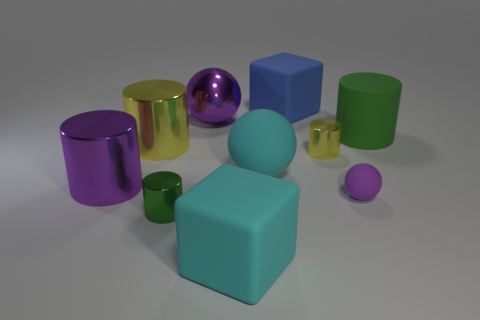Subtract all purple cylinders. How many cylinders are left? 4 Subtract all green blocks. How many yellow cylinders are left? 2 Subtract all yellow cylinders. How many cylinders are left? 3 Subtract 1 balls. How many balls are left? 2 Subtract all spheres. How many objects are left? 7 Subtract all gray spheres. Subtract all yellow blocks. How many spheres are left? 3 Subtract all small yellow cylinders. Subtract all small yellow objects. How many objects are left? 8 Add 8 small spheres. How many small spheres are left? 9 Add 4 big cyan matte balls. How many big cyan matte balls exist? 5 Subtract 0 purple blocks. How many objects are left? 10 